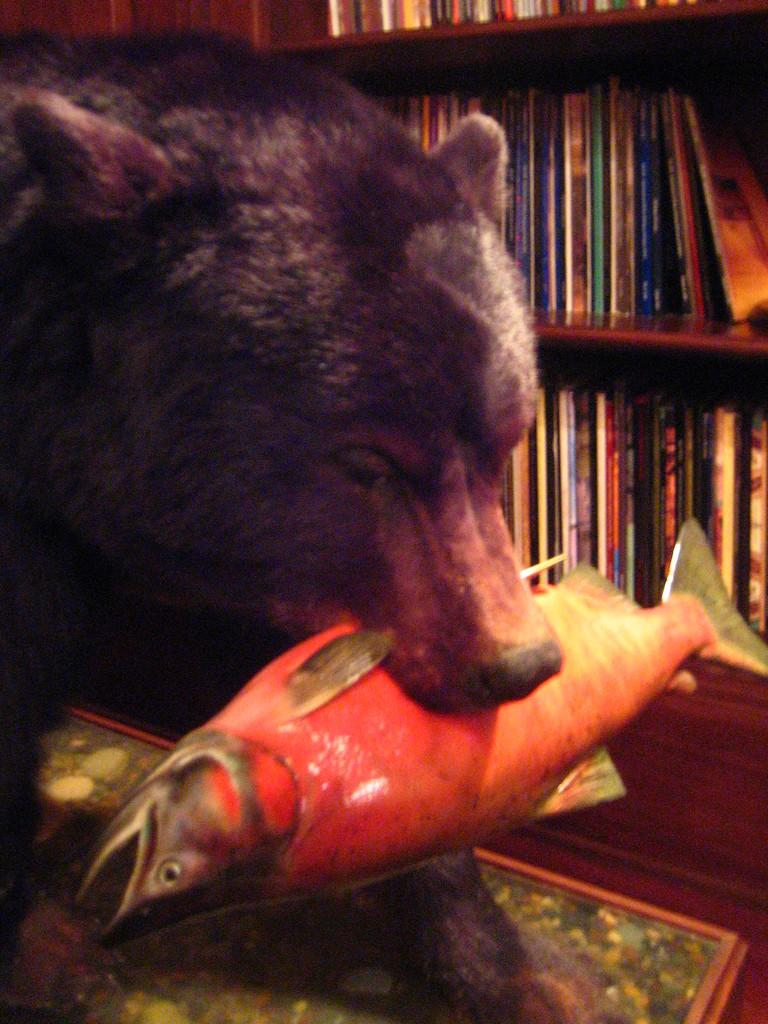What type of animal can be seen in the image? There is an animal in the image, but its specific species cannot be determined from the facts provided. How is the animal interacting with the fish in the image? The animal is holding a fish with its mouth. What can be seen on the shelves in the background of the image? The shelves have books on them. Where is the animal standing in the image? The animal is standing on the floor. What type of flooring is present in the image? There is a carpet on the floor. What type of advertisement can be seen on the board in the image? There is no board or advertisement present in the image. Can you tell me how many cellar doors are visible in the image? There is no mention of cellar doors in the image, so it cannot be determined from the facts provided. 